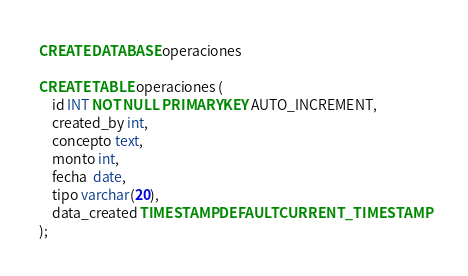Convert code to text. <code><loc_0><loc_0><loc_500><loc_500><_SQL_>CREATE DATABASE operaciones

CREATE TABLE operaciones (
	id INT NOT NULL PRIMARY KEY AUTO_INCREMENT, 
    created_by int,
	concepto text,
    monto int,
    fecha  date,
    tipo varchar(20),
    data_created TIMESTAMP DEFAULT CURRENT_TIMESTAMP 
);</code> 